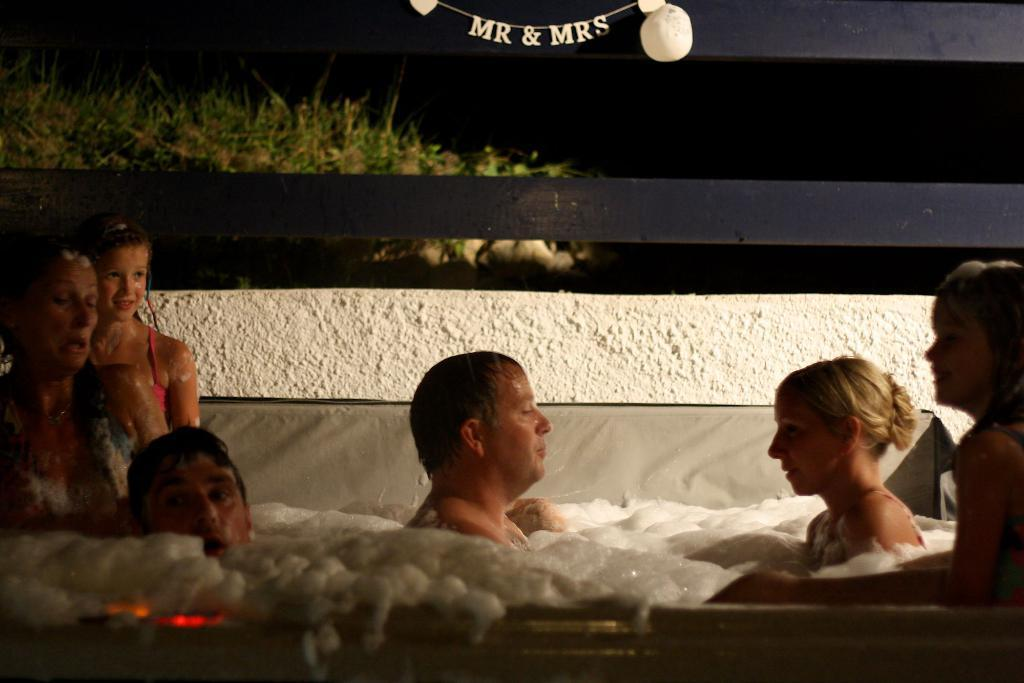What are the people in the image doing? There are people in the bathtub in the center of the image. What can be seen in the background of the image? There is a wooden fencing in the background of the image. What type of vegetation is visible in the image? There is grass visible in the image. What type of pancake is being served on the wooden fencing in the image? There is no pancake present in the image; it features people in a bathtub and a wooden fencing in the background. 